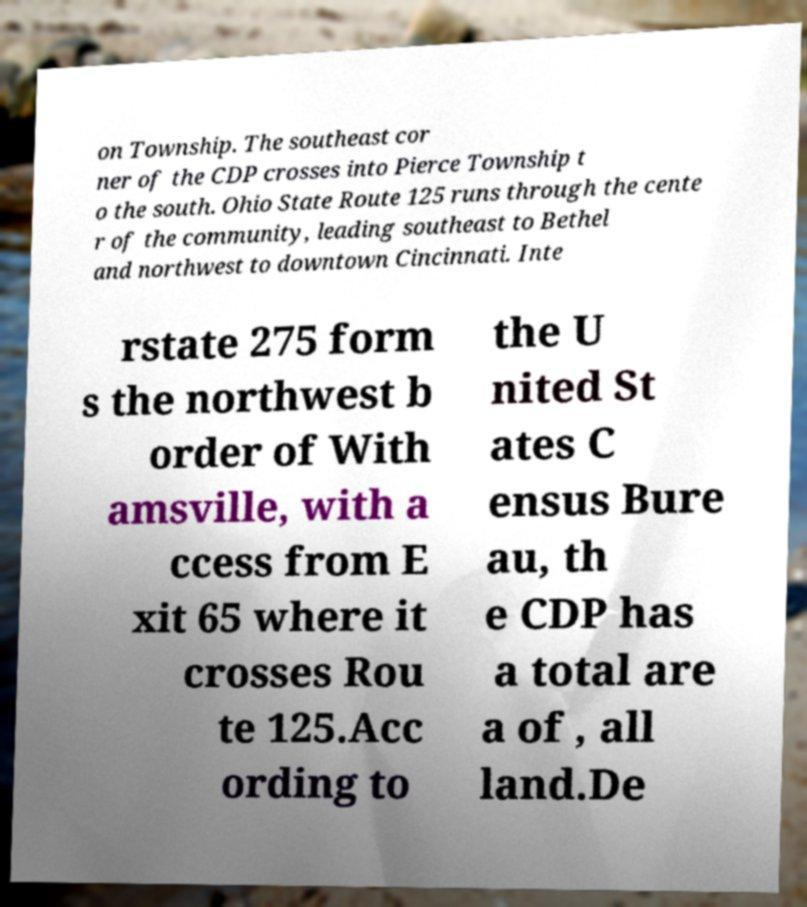Could you assist in decoding the text presented in this image and type it out clearly? on Township. The southeast cor ner of the CDP crosses into Pierce Township t o the south. Ohio State Route 125 runs through the cente r of the community, leading southeast to Bethel and northwest to downtown Cincinnati. Inte rstate 275 form s the northwest b order of With amsville, with a ccess from E xit 65 where it crosses Rou te 125.Acc ording to the U nited St ates C ensus Bure au, th e CDP has a total are a of , all land.De 